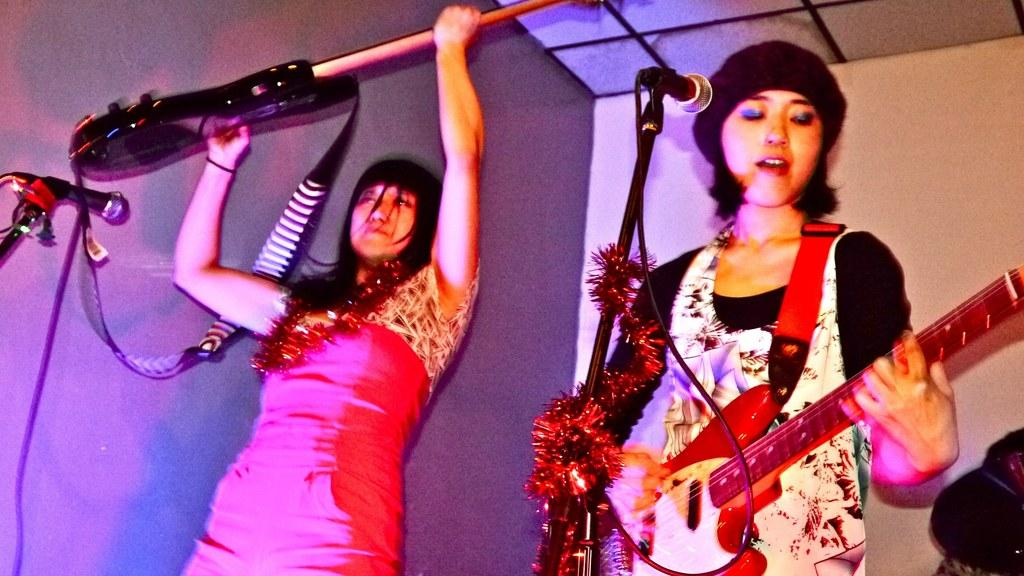How many people are in the image? There are two women in the image. What are the women holding in the image? The women are holding guitars. What activity are the women engaged in? The women are singing songs. What object is in front of the women? There is a microphone in front of them. What type of trousers are the women wearing in the image? The provided facts do not mention the type of trousers the women are wearing, so we cannot answer this question definitively. 